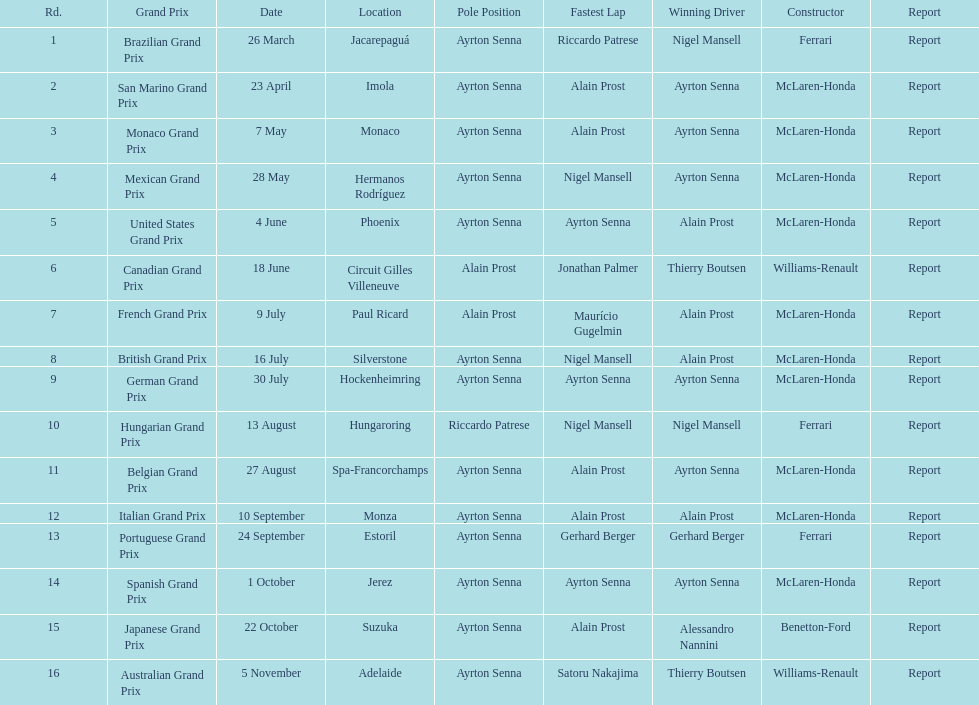Before the san marino grand prix, which grand prix was held? Brazilian Grand Prix. 